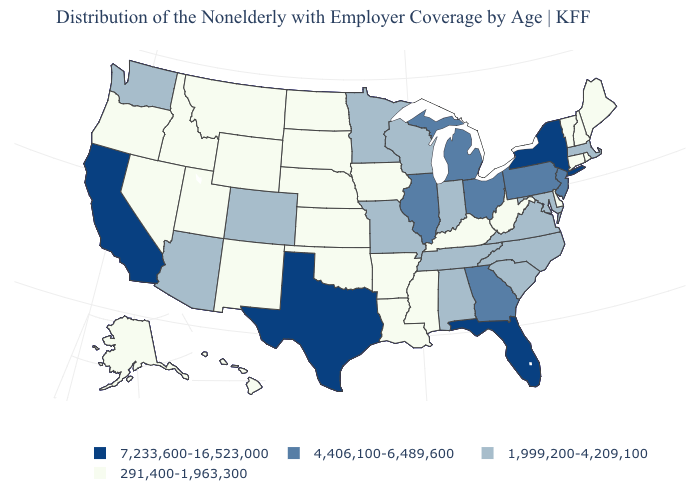Among the states that border Rhode Island , which have the lowest value?
Concise answer only. Connecticut. What is the value of Tennessee?
Keep it brief. 1,999,200-4,209,100. What is the value of Wisconsin?
Quick response, please. 1,999,200-4,209,100. Name the states that have a value in the range 1,999,200-4,209,100?
Short answer required. Alabama, Arizona, Colorado, Indiana, Maryland, Massachusetts, Minnesota, Missouri, North Carolina, South Carolina, Tennessee, Virginia, Washington, Wisconsin. What is the lowest value in the Northeast?
Quick response, please. 291,400-1,963,300. Does Texas have the highest value in the South?
Short answer required. Yes. Among the states that border Nebraska , does Colorado have the highest value?
Concise answer only. Yes. Name the states that have a value in the range 4,406,100-6,489,600?
Answer briefly. Georgia, Illinois, Michigan, New Jersey, Ohio, Pennsylvania. Name the states that have a value in the range 1,999,200-4,209,100?
Keep it brief. Alabama, Arizona, Colorado, Indiana, Maryland, Massachusetts, Minnesota, Missouri, North Carolina, South Carolina, Tennessee, Virginia, Washington, Wisconsin. Which states have the highest value in the USA?
Short answer required. California, Florida, New York, Texas. Which states have the highest value in the USA?
Keep it brief. California, Florida, New York, Texas. What is the value of Kentucky?
Be succinct. 291,400-1,963,300. Is the legend a continuous bar?
Short answer required. No. What is the value of Nevada?
Answer briefly. 291,400-1,963,300. 